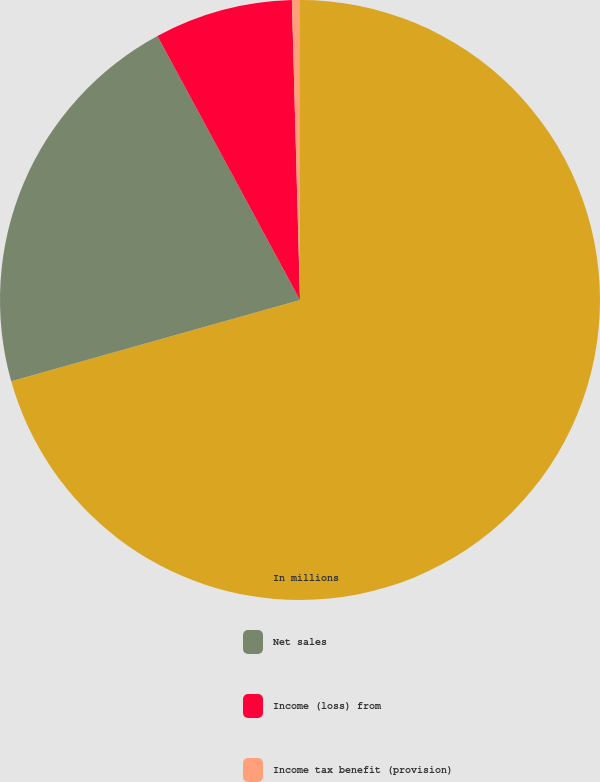<chart> <loc_0><loc_0><loc_500><loc_500><pie_chart><fcel>In millions<fcel>Net sales<fcel>Income (loss) from<fcel>Income tax benefit (provision)<nl><fcel>70.63%<fcel>21.49%<fcel>7.45%<fcel>0.43%<nl></chart> 